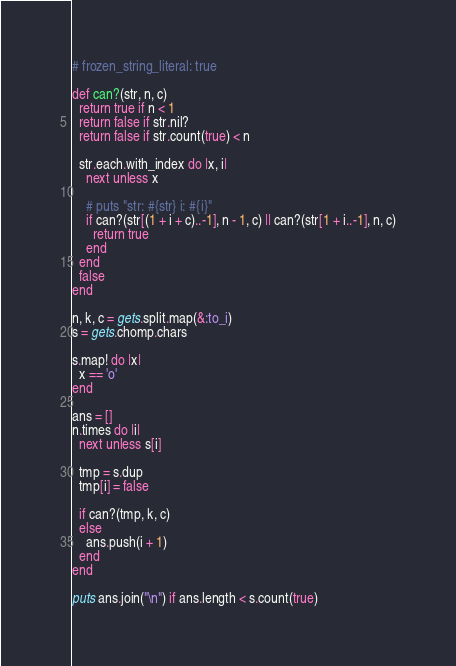Convert code to text. <code><loc_0><loc_0><loc_500><loc_500><_Ruby_># frozen_string_literal: true

def can?(str, n, c)
  return true if n < 1
  return false if str.nil?
  return false if str.count(true) < n

  str.each.with_index do |x, i|
    next unless x

    # puts "str: #{str} i: #{i}"
    if can?(str[(1 + i + c)..-1], n - 1, c) || can?(str[1 + i..-1], n, c)
      return true
    end
  end
  false
end

n, k, c = gets.split.map(&:to_i)
s = gets.chomp.chars

s.map! do |x|
  x == 'o'
end

ans = []
n.times do |i|
  next unless s[i]

  tmp = s.dup
  tmp[i] = false

  if can?(tmp, k, c)
  else
    ans.push(i + 1)
  end
end

puts ans.join("\n") if ans.length < s.count(true)
</code> 